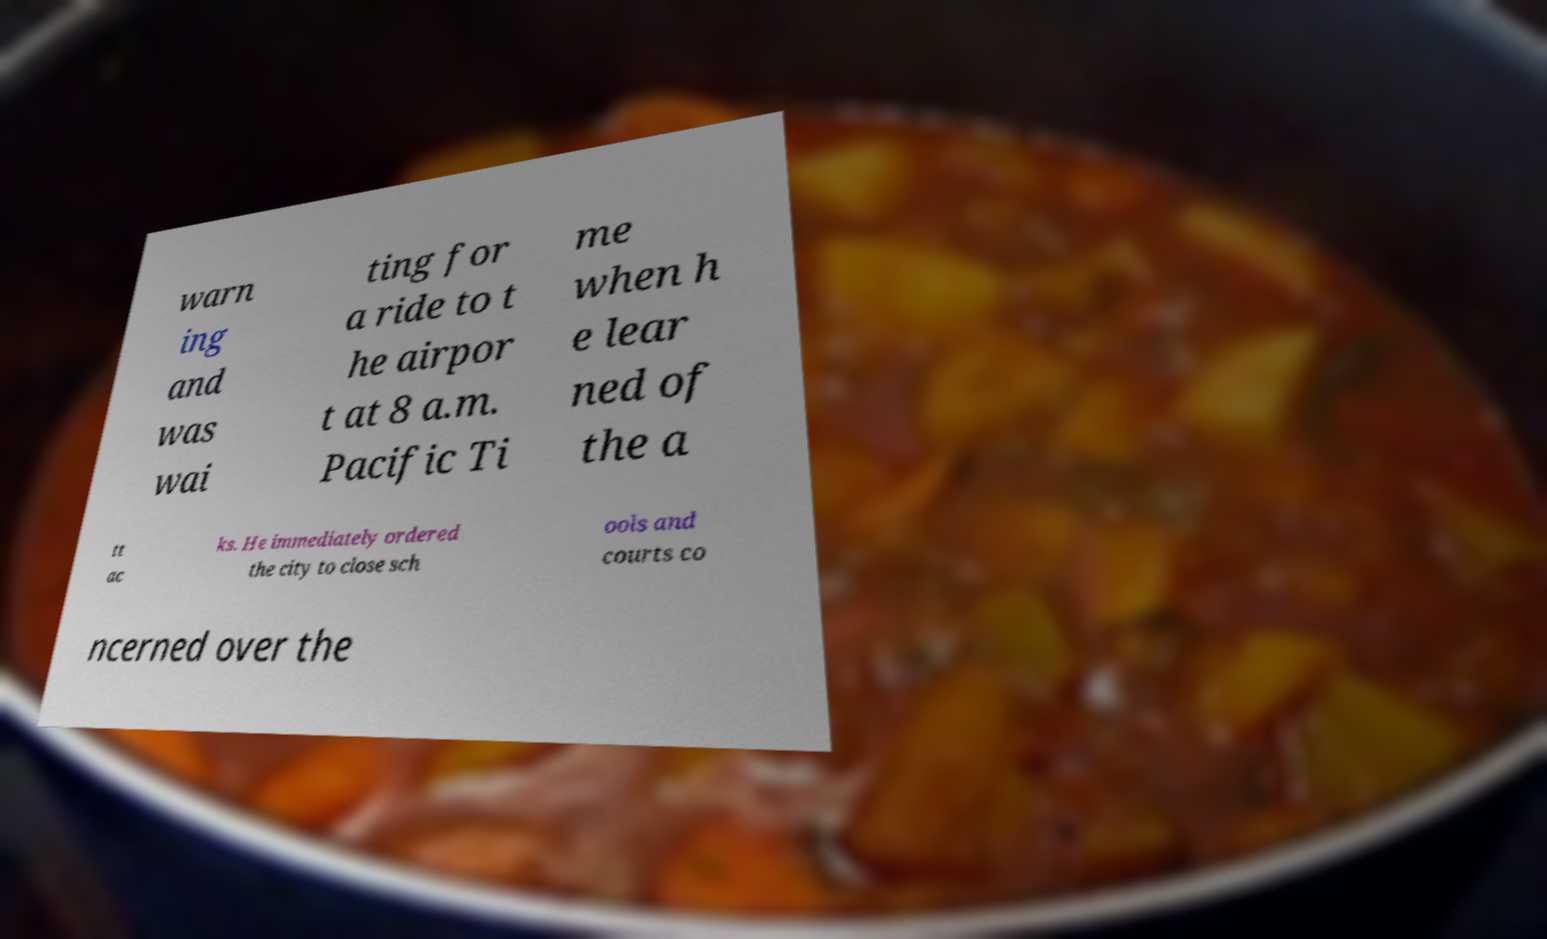For documentation purposes, I need the text within this image transcribed. Could you provide that? warn ing and was wai ting for a ride to t he airpor t at 8 a.m. Pacific Ti me when h e lear ned of the a tt ac ks. He immediately ordered the city to close sch ools and courts co ncerned over the 